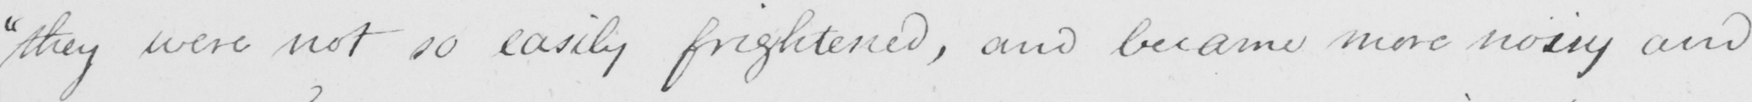Transcribe the text shown in this historical manuscript line. " they were not so easily frightened , and became more noisy and 